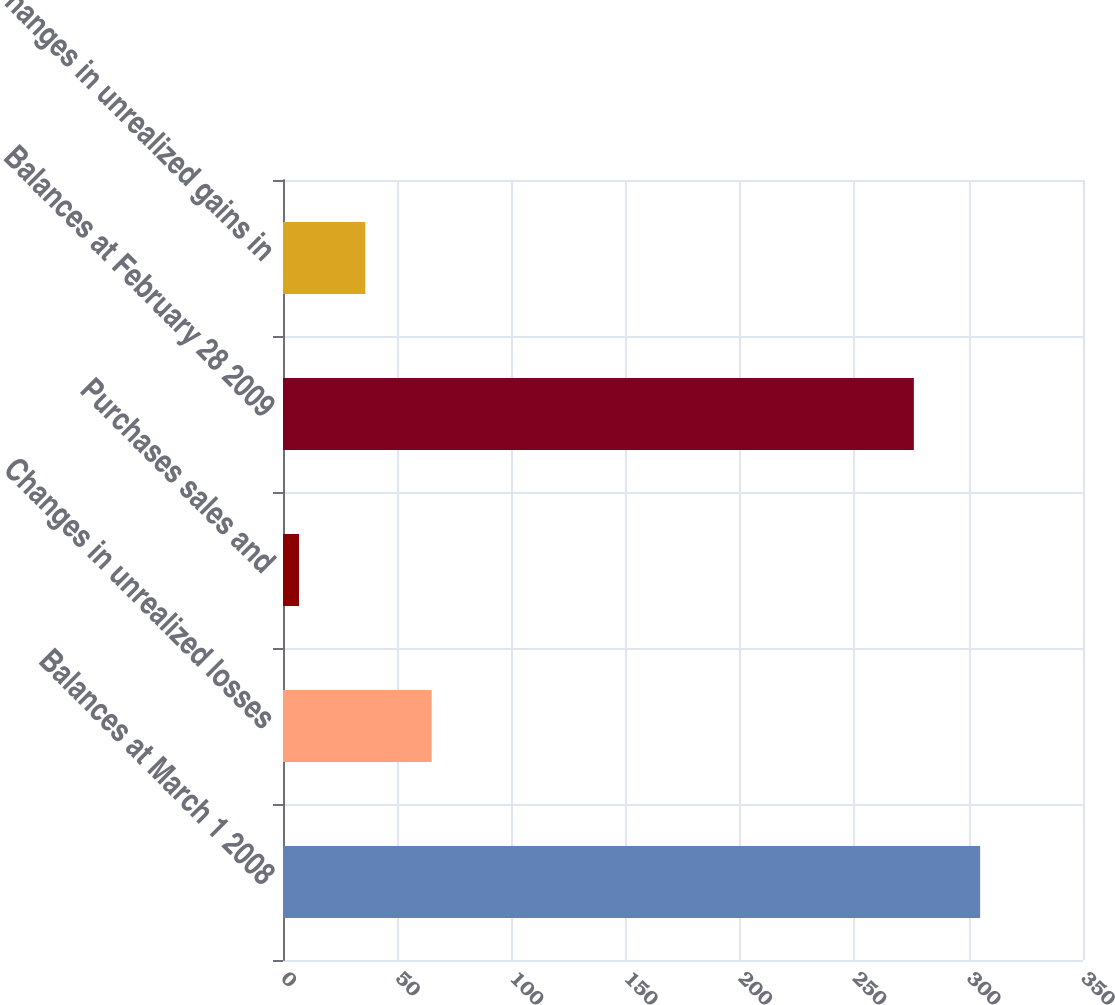<chart> <loc_0><loc_0><loc_500><loc_500><bar_chart><fcel>Balances at March 1 2008<fcel>Changes in unrealized losses<fcel>Purchases sales and<fcel>Balances at February 28 2009<fcel>Changes in unrealized gains in<nl><fcel>305<fcel>65<fcel>7<fcel>276<fcel>36<nl></chart> 